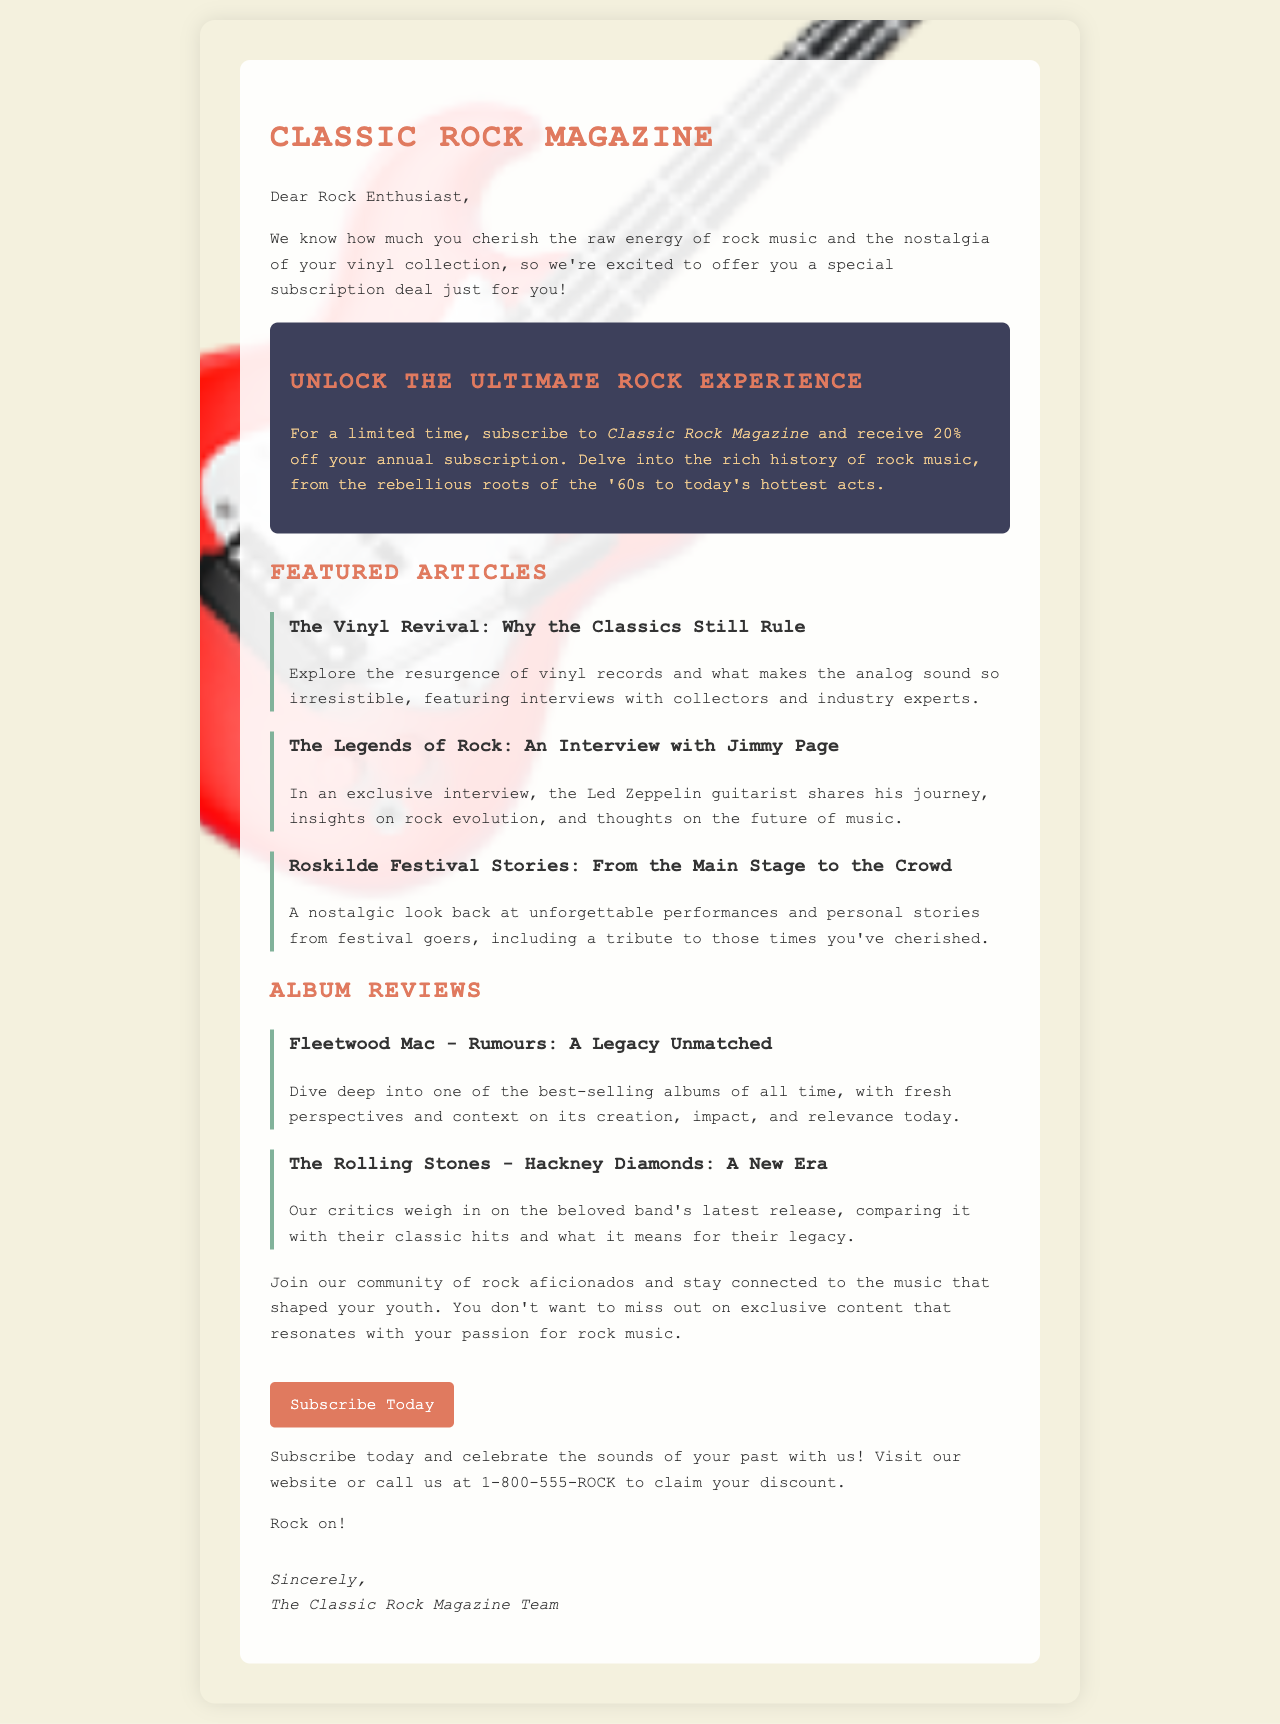What is the name of the magazine? The document introduces a magazine focused on rock music, indicating its name in the header and the text.
Answer: Classic Rock Magazine What is the discount percentage offered for the subscription? The document specifies that there is a promotional subscription deal available for a limited time, detailing the discount percentage prominently in the offer section.
Answer: 20% Who is featured in the exclusive interview? The document mentions an exclusive interview with a well-known rock guitarist, which is clearly stated in the article section.
Answer: Jimmy Page What is one album reviewed in the document? The document includes mentions of specific albums in the album review section.
Answer: Rumours What festival is mentioned in the letter? The document reflects on personal stories related to a popular music festival known for its rock music, which is indicated in the articles section.
Answer: Roskilde Festival What is the call-to-action in the document? The document concludes with a clear action statement encouraging readers to engage with the content and subscription offer.
Answer: Subscribe Today What type of content does the magazine focus on? The letter outlines the main themes of the magazine, emphasizing the historical context and artist-focused content.
Answer: Rock music history When can subscribers claim their discount? The document specifies that the discount is available for a limited time, emphasizing urgency in the subscription offer.
Answer: Now 